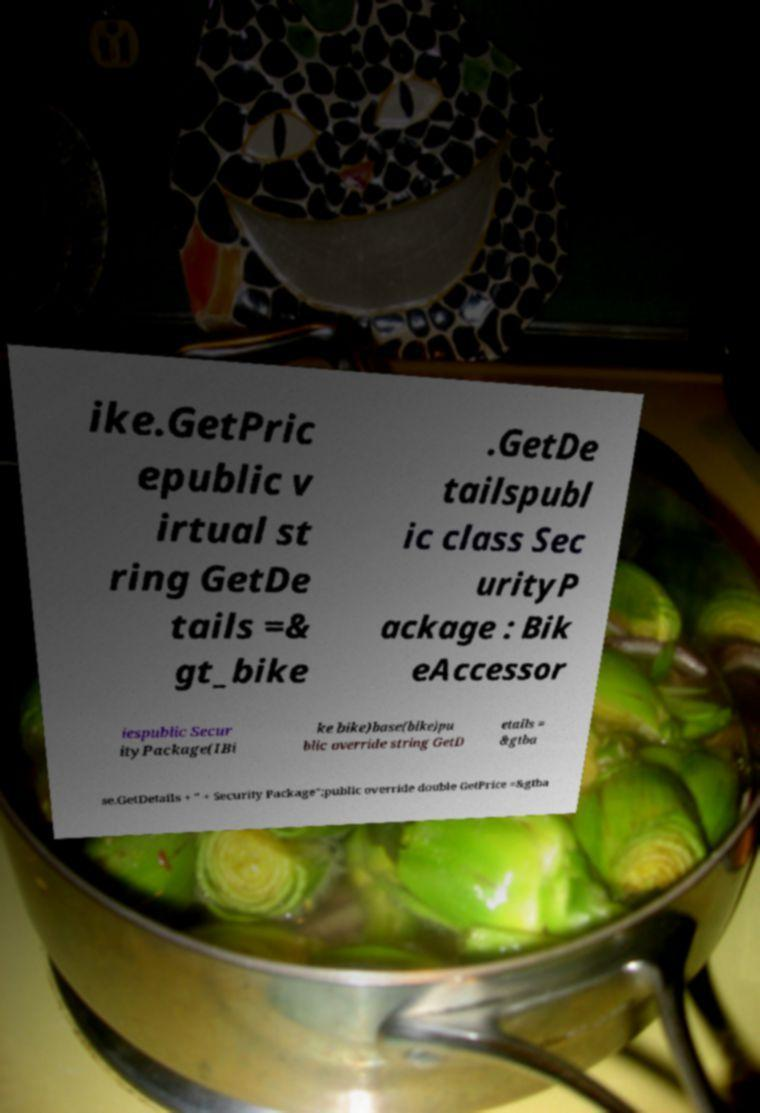What messages or text are displayed in this image? I need them in a readable, typed format. ike.GetPric epublic v irtual st ring GetDe tails =& gt_bike .GetDe tailspubl ic class Sec urityP ackage : Bik eAccessor iespublic Secur ityPackage(IBi ke bike)base(bike)pu blic override string GetD etails = &gtba se.GetDetails + " + Security Package";public override double GetPrice =&gtba 